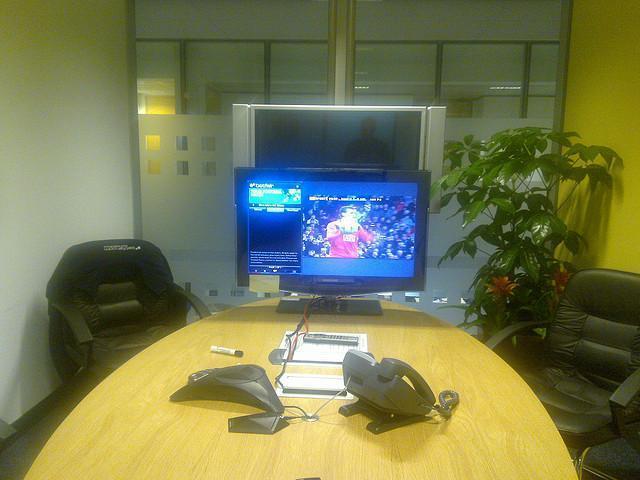How many chairs can be seen?
Give a very brief answer. 2. How many dining tables are in the picture?
Give a very brief answer. 1. How many tvs are in the photo?
Give a very brief answer. 2. 